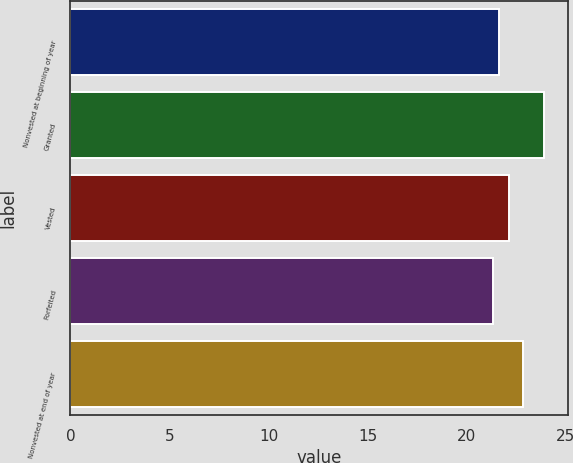Convert chart to OTSL. <chart><loc_0><loc_0><loc_500><loc_500><bar_chart><fcel>Nonvested at beginning of year<fcel>Granted<fcel>Vested<fcel>Forfeited<fcel>Nonvested at end of year<nl><fcel>21.61<fcel>23.9<fcel>22.15<fcel>21.35<fcel>22.84<nl></chart> 